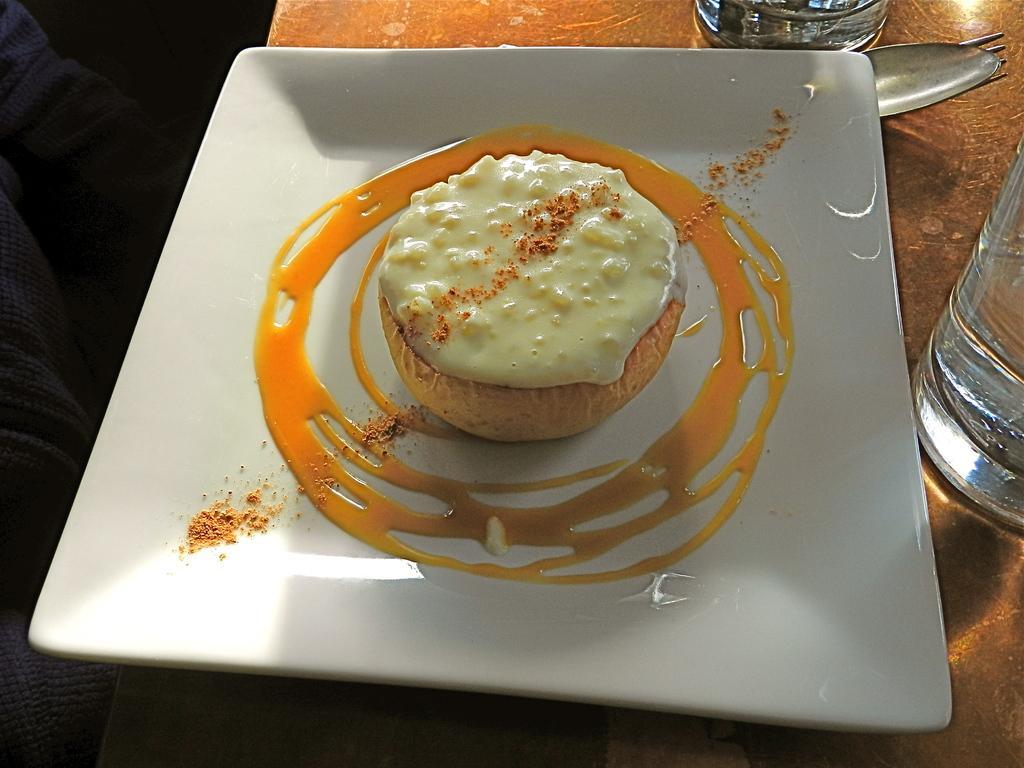How would you summarize this image in a sentence or two? In this picture it looks like a dessert with sauce dressing around it kept on a white plate. 